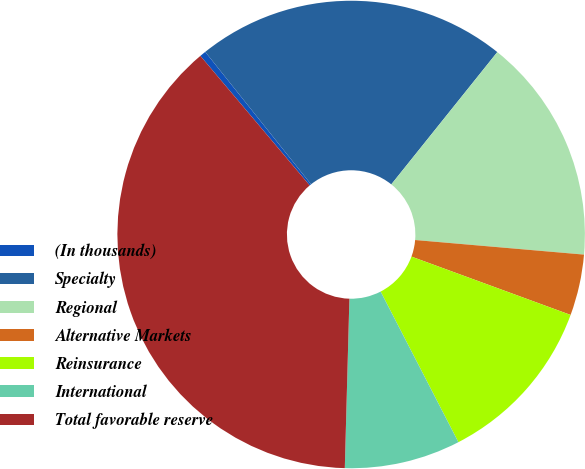Convert chart. <chart><loc_0><loc_0><loc_500><loc_500><pie_chart><fcel>(In thousands)<fcel>Specialty<fcel>Regional<fcel>Alternative Markets<fcel>Reinsurance<fcel>International<fcel>Total favorable reserve<nl><fcel>0.43%<fcel>21.48%<fcel>15.62%<fcel>4.22%<fcel>11.82%<fcel>8.02%<fcel>38.41%<nl></chart> 